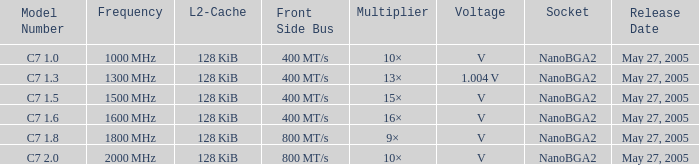What is the Frequency for Model Number c7 1.0? 1000 MHz. 